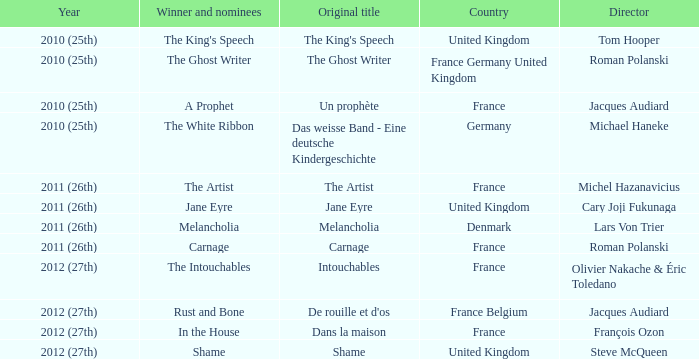Who was the winner and nominees for the movie directed by cary joji fukunaga? Jane Eyre. 